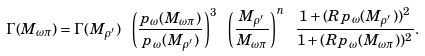<formula> <loc_0><loc_0><loc_500><loc_500>\Gamma ( M _ { \omega \pi } ) = \Gamma ( M _ { \rho ^ { \prime } } ) \ \left ( \frac { p _ { \omega } ( M _ { \omega \pi } ) } { p _ { \omega } ( M _ { \rho ^ { \prime } } ) } \right ) ^ { 3 } \ \left ( \frac { M _ { \rho ^ { \prime } } } { M _ { \omega \pi } } \right ) ^ { n } \ \frac { 1 + ( R p _ { \omega } ( M _ { \rho ^ { \prime } } ) ) ^ { 2 } } { 1 + ( R p _ { \omega } ( M _ { \omega \pi } ) ) ^ { 2 } } .</formula> 